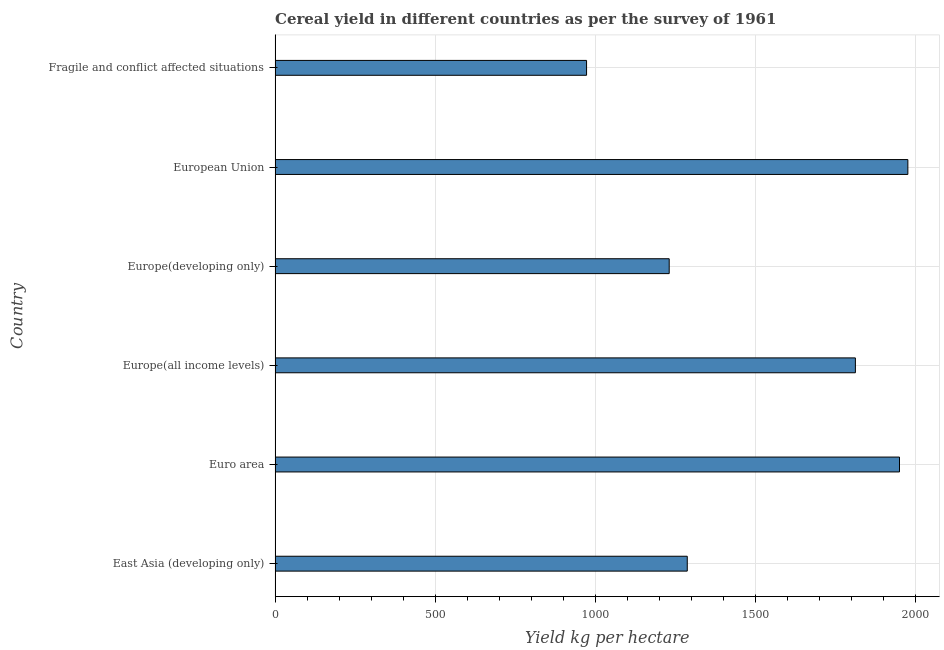Does the graph contain any zero values?
Keep it short and to the point. No. Does the graph contain grids?
Make the answer very short. Yes. What is the title of the graph?
Provide a succinct answer. Cereal yield in different countries as per the survey of 1961. What is the label or title of the X-axis?
Ensure brevity in your answer.  Yield kg per hectare. What is the cereal yield in Euro area?
Provide a succinct answer. 1951.5. Across all countries, what is the maximum cereal yield?
Offer a very short reply. 1977.62. Across all countries, what is the minimum cereal yield?
Provide a succinct answer. 973.47. In which country was the cereal yield minimum?
Offer a very short reply. Fragile and conflict affected situations. What is the sum of the cereal yield?
Ensure brevity in your answer.  9236.21. What is the difference between the cereal yield in Europe(all income levels) and Europe(developing only)?
Provide a succinct answer. 581.9. What is the average cereal yield per country?
Keep it short and to the point. 1539.37. What is the median cereal yield?
Make the answer very short. 1550.93. In how many countries, is the cereal yield greater than 1200 kg per hectare?
Give a very brief answer. 5. What is the ratio of the cereal yield in European Union to that in Fragile and conflict affected situations?
Offer a terse response. 2.03. Is the cereal yield in Euro area less than that in Europe(developing only)?
Give a very brief answer. No. Is the difference between the cereal yield in European Union and Fragile and conflict affected situations greater than the difference between any two countries?
Give a very brief answer. Yes. What is the difference between the highest and the second highest cereal yield?
Your answer should be very brief. 26.11. Is the sum of the cereal yield in Europe(all income levels) and European Union greater than the maximum cereal yield across all countries?
Give a very brief answer. Yes. What is the difference between the highest and the lowest cereal yield?
Give a very brief answer. 1004.15. In how many countries, is the cereal yield greater than the average cereal yield taken over all countries?
Provide a succinct answer. 3. How many countries are there in the graph?
Provide a succinct answer. 6. Are the values on the major ticks of X-axis written in scientific E-notation?
Your response must be concise. No. What is the Yield kg per hectare of East Asia (developing only)?
Provide a succinct answer. 1288.2. What is the Yield kg per hectare of Euro area?
Provide a succinct answer. 1951.5. What is the Yield kg per hectare of Europe(all income levels)?
Make the answer very short. 1813.66. What is the Yield kg per hectare of Europe(developing only)?
Give a very brief answer. 1231.76. What is the Yield kg per hectare of European Union?
Give a very brief answer. 1977.62. What is the Yield kg per hectare of Fragile and conflict affected situations?
Your answer should be very brief. 973.47. What is the difference between the Yield kg per hectare in East Asia (developing only) and Euro area?
Your answer should be very brief. -663.31. What is the difference between the Yield kg per hectare in East Asia (developing only) and Europe(all income levels)?
Your answer should be very brief. -525.46. What is the difference between the Yield kg per hectare in East Asia (developing only) and Europe(developing only)?
Provide a succinct answer. 56.44. What is the difference between the Yield kg per hectare in East Asia (developing only) and European Union?
Ensure brevity in your answer.  -689.42. What is the difference between the Yield kg per hectare in East Asia (developing only) and Fragile and conflict affected situations?
Provide a succinct answer. 314.73. What is the difference between the Yield kg per hectare in Euro area and Europe(all income levels)?
Give a very brief answer. 137.84. What is the difference between the Yield kg per hectare in Euro area and Europe(developing only)?
Your answer should be compact. 719.74. What is the difference between the Yield kg per hectare in Euro area and European Union?
Keep it short and to the point. -26.12. What is the difference between the Yield kg per hectare in Euro area and Fragile and conflict affected situations?
Give a very brief answer. 978.03. What is the difference between the Yield kg per hectare in Europe(all income levels) and Europe(developing only)?
Give a very brief answer. 581.9. What is the difference between the Yield kg per hectare in Europe(all income levels) and European Union?
Your response must be concise. -163.96. What is the difference between the Yield kg per hectare in Europe(all income levels) and Fragile and conflict affected situations?
Give a very brief answer. 840.19. What is the difference between the Yield kg per hectare in Europe(developing only) and European Union?
Give a very brief answer. -745.86. What is the difference between the Yield kg per hectare in Europe(developing only) and Fragile and conflict affected situations?
Your response must be concise. 258.29. What is the difference between the Yield kg per hectare in European Union and Fragile and conflict affected situations?
Provide a short and direct response. 1004.15. What is the ratio of the Yield kg per hectare in East Asia (developing only) to that in Euro area?
Provide a succinct answer. 0.66. What is the ratio of the Yield kg per hectare in East Asia (developing only) to that in Europe(all income levels)?
Provide a short and direct response. 0.71. What is the ratio of the Yield kg per hectare in East Asia (developing only) to that in Europe(developing only)?
Your answer should be compact. 1.05. What is the ratio of the Yield kg per hectare in East Asia (developing only) to that in European Union?
Your answer should be compact. 0.65. What is the ratio of the Yield kg per hectare in East Asia (developing only) to that in Fragile and conflict affected situations?
Provide a short and direct response. 1.32. What is the ratio of the Yield kg per hectare in Euro area to that in Europe(all income levels)?
Provide a succinct answer. 1.08. What is the ratio of the Yield kg per hectare in Euro area to that in Europe(developing only)?
Make the answer very short. 1.58. What is the ratio of the Yield kg per hectare in Euro area to that in European Union?
Make the answer very short. 0.99. What is the ratio of the Yield kg per hectare in Euro area to that in Fragile and conflict affected situations?
Your response must be concise. 2. What is the ratio of the Yield kg per hectare in Europe(all income levels) to that in Europe(developing only)?
Your response must be concise. 1.47. What is the ratio of the Yield kg per hectare in Europe(all income levels) to that in European Union?
Your answer should be compact. 0.92. What is the ratio of the Yield kg per hectare in Europe(all income levels) to that in Fragile and conflict affected situations?
Make the answer very short. 1.86. What is the ratio of the Yield kg per hectare in Europe(developing only) to that in European Union?
Ensure brevity in your answer.  0.62. What is the ratio of the Yield kg per hectare in Europe(developing only) to that in Fragile and conflict affected situations?
Your answer should be compact. 1.26. What is the ratio of the Yield kg per hectare in European Union to that in Fragile and conflict affected situations?
Your answer should be compact. 2.03. 